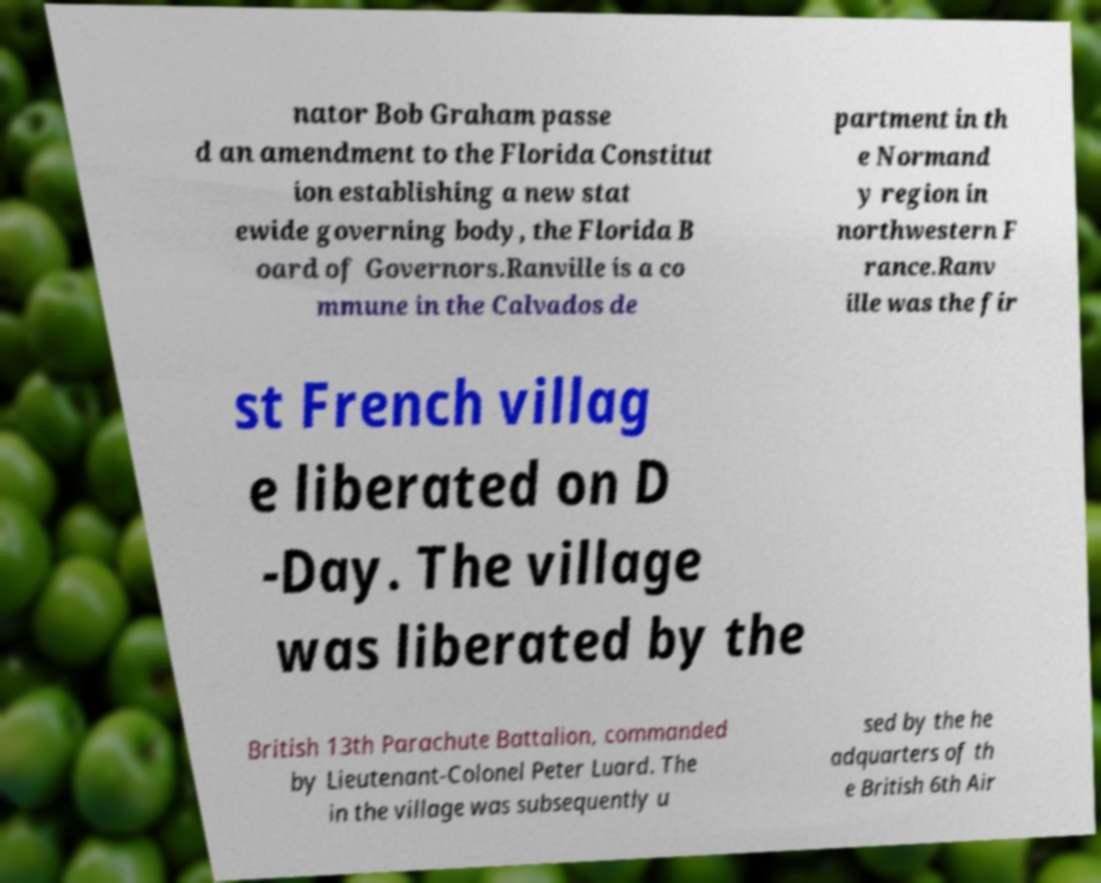Could you assist in decoding the text presented in this image and type it out clearly? nator Bob Graham passe d an amendment to the Florida Constitut ion establishing a new stat ewide governing body, the Florida B oard of Governors.Ranville is a co mmune in the Calvados de partment in th e Normand y region in northwestern F rance.Ranv ille was the fir st French villag e liberated on D -Day. The village was liberated by the British 13th Parachute Battalion, commanded by Lieutenant-Colonel Peter Luard. The in the village was subsequently u sed by the he adquarters of th e British 6th Air 